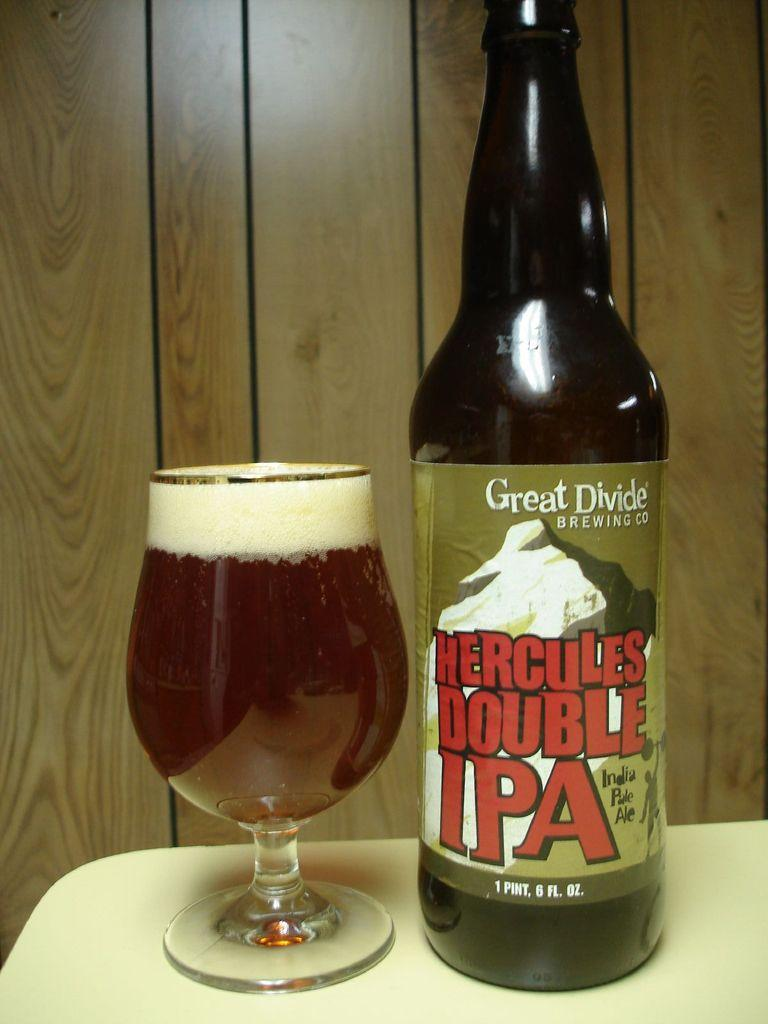<image>
Present a compact description of the photo's key features. A bottle labeled Hercules Double IPA is next to a glass. 